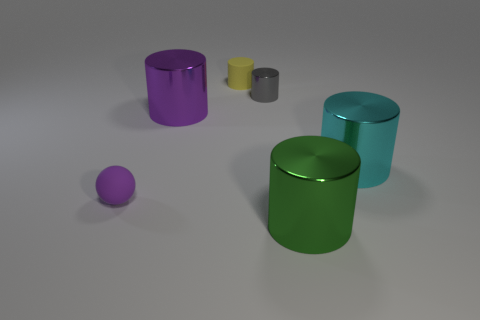Can you tell me the possible functions of these objects? Without additional context, the shapes and sizes of these objects suggest they could be decorative pieces, or they might serve as containers or storage units if they have openable lids. Their simple geometric shapes and lack of visible features such as handles or spouts make it difficult to determine a specific function beyond ornamental or abstract uses. 